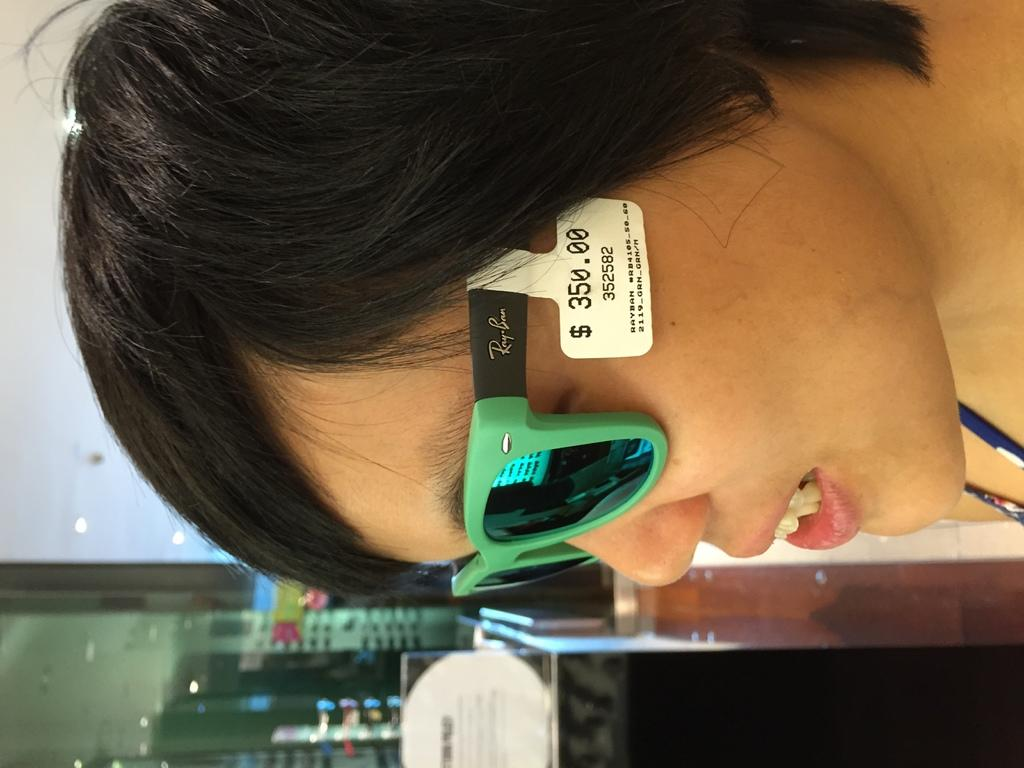What is present in the image? There is a person in the image. Can you describe the person's appearance? The person is wearing glasses. Does the person have any identifiers or accessories? The person has a tag. What can be seen in the background of the image? There are stands, a glass door, lights, a board, some objects, and a wall in the background of the image. Can you tell me how many times the person jumps in the image? There is no indication of the person jumping in the image. What type of button is the person wearing in the image? There is no button mentioned or visible in the image. 